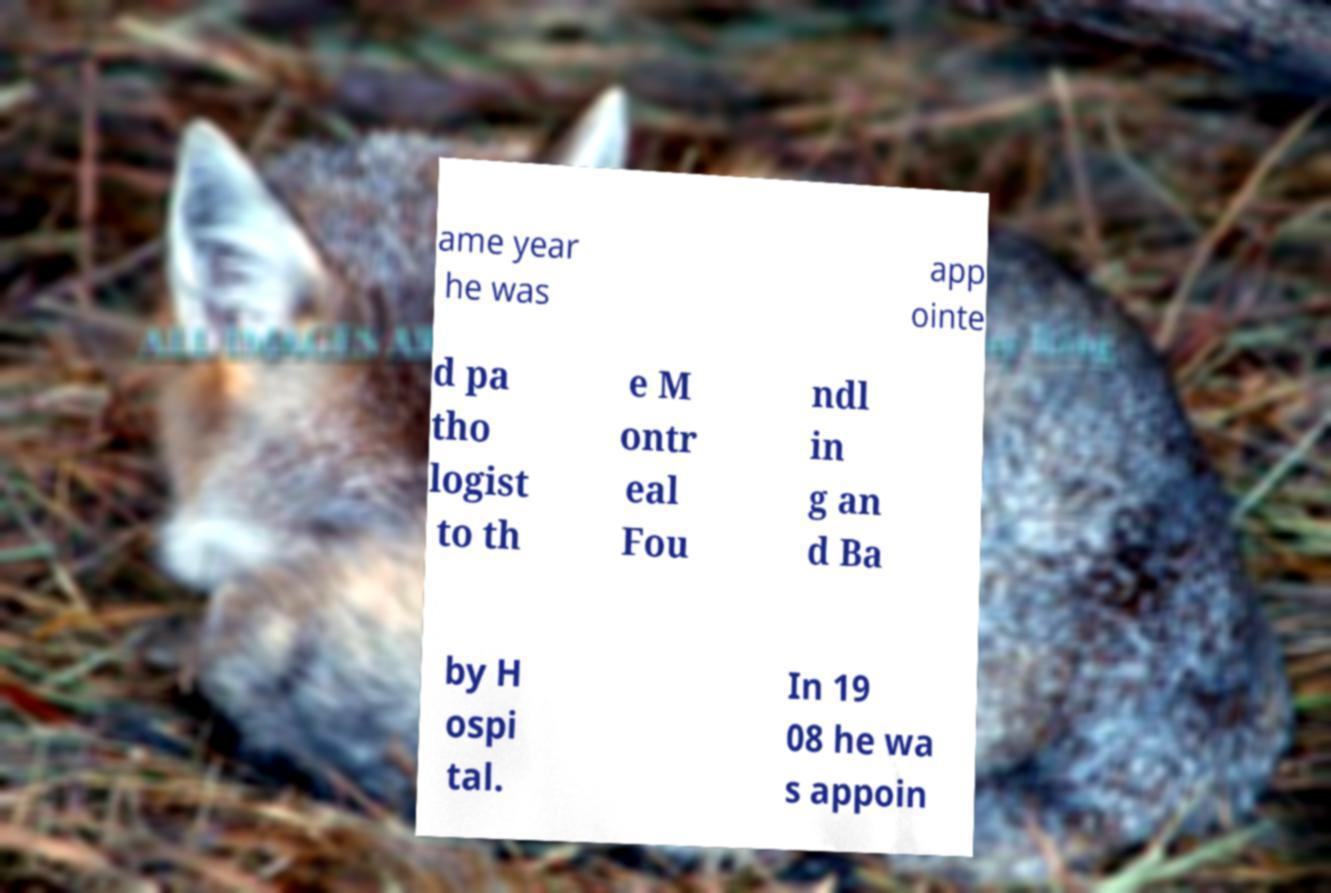There's text embedded in this image that I need extracted. Can you transcribe it verbatim? ame year he was app ointe d pa tho logist to th e M ontr eal Fou ndl in g an d Ba by H ospi tal. In 19 08 he wa s appoin 